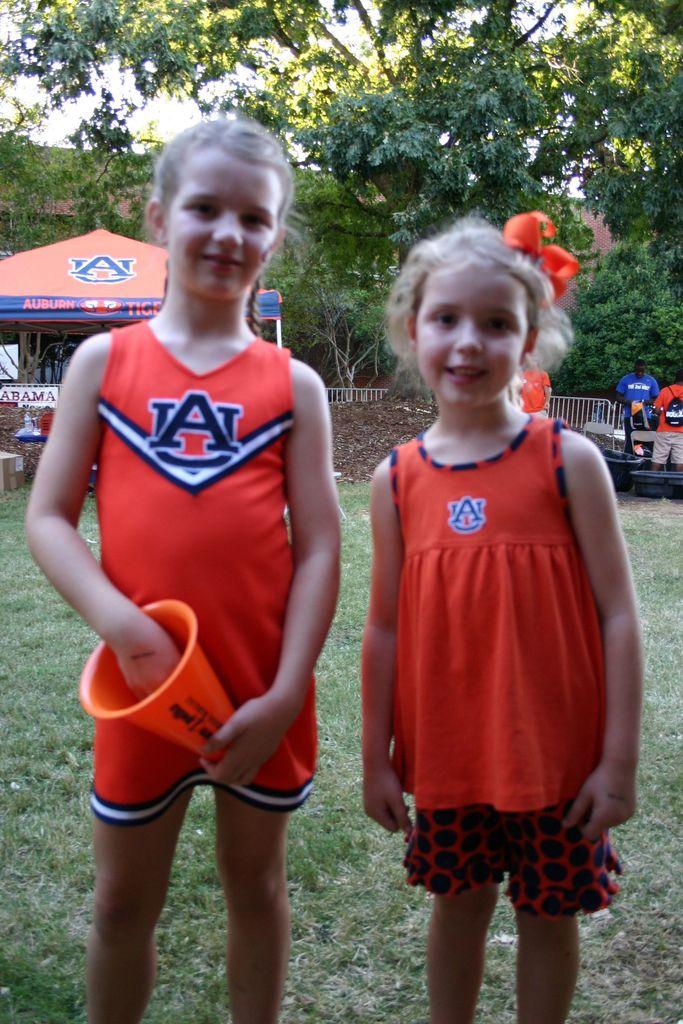What letters are on their fress?
Give a very brief answer. Au. What city is on the tent in the background?
Keep it short and to the point. Auburn. 